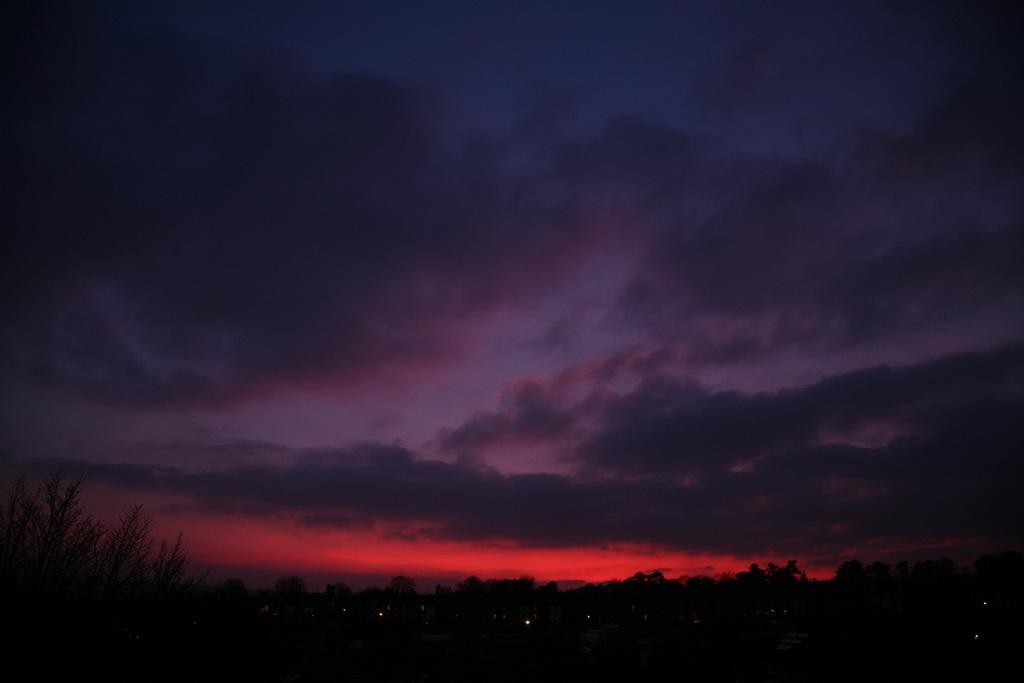What time of day was the image taken? The image was taken during the evening. What can be seen at the bottom of the image? There are trees at the bottom of the image. What is visible at the top of the image? There is a sky visible at the top of the image. What can be observed in the sky? Clouds are present in the sky, and a sunset is visible. What page of the book is the face of the character on in the image? There is no book or face present in the image; it features a sky with clouds and a sunset. 